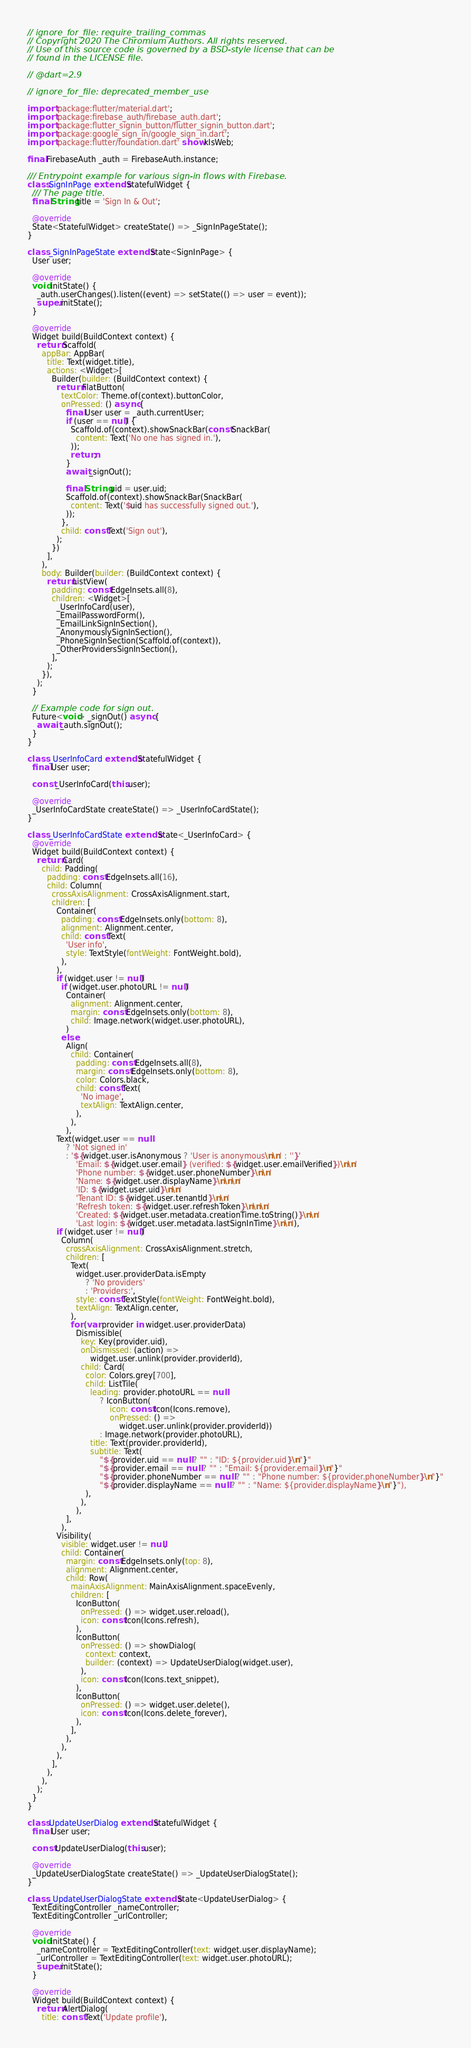Convert code to text. <code><loc_0><loc_0><loc_500><loc_500><_Dart_>// ignore_for_file: require_trailing_commas
// Copyright 2020 The Chromium Authors. All rights reserved.
// Use of this source code is governed by a BSD-style license that can be
// found in the LICENSE file.

// @dart=2.9

// ignore_for_file: deprecated_member_use

import 'package:flutter/material.dart';
import 'package:firebase_auth/firebase_auth.dart';
import 'package:flutter_signin_button/flutter_signin_button.dart';
import 'package:google_sign_in/google_sign_in.dart';
import 'package:flutter/foundation.dart' show kIsWeb;

final FirebaseAuth _auth = FirebaseAuth.instance;

/// Entrypoint example for various sign-in flows with Firebase.
class SignInPage extends StatefulWidget {
  /// The page title.
  final String title = 'Sign In & Out';

  @override
  State<StatefulWidget> createState() => _SignInPageState();
}

class _SignInPageState extends State<SignInPage> {
  User user;

  @override
  void initState() {
    _auth.userChanges().listen((event) => setState(() => user = event));
    super.initState();
  }

  @override
  Widget build(BuildContext context) {
    return Scaffold(
      appBar: AppBar(
        title: Text(widget.title),
        actions: <Widget>[
          Builder(builder: (BuildContext context) {
            return FlatButton(
              textColor: Theme.of(context).buttonColor,
              onPressed: () async {
                final User user = _auth.currentUser;
                if (user == null) {
                  Scaffold.of(context).showSnackBar(const SnackBar(
                    content: Text('No one has signed in.'),
                  ));
                  return;
                }
                await _signOut();

                final String uid = user.uid;
                Scaffold.of(context).showSnackBar(SnackBar(
                  content: Text('$uid has successfully signed out.'),
                ));
              },
              child: const Text('Sign out'),
            );
          })
        ],
      ),
      body: Builder(builder: (BuildContext context) {
        return ListView(
          padding: const EdgeInsets.all(8),
          children: <Widget>[
            _UserInfoCard(user),
            _EmailPasswordForm(),
            _EmailLinkSignInSection(),
            _AnonymouslySignInSection(),
            _PhoneSignInSection(Scaffold.of(context)),
            _OtherProvidersSignInSection(),
          ],
        );
      }),
    );
  }

  // Example code for sign out.
  Future<void> _signOut() async {
    await _auth.signOut();
  }
}

class _UserInfoCard extends StatefulWidget {
  final User user;

  const _UserInfoCard(this.user);

  @override
  _UserInfoCardState createState() => _UserInfoCardState();
}

class _UserInfoCardState extends State<_UserInfoCard> {
  @override
  Widget build(BuildContext context) {
    return Card(
      child: Padding(
        padding: const EdgeInsets.all(16),
        child: Column(
          crossAxisAlignment: CrossAxisAlignment.start,
          children: [
            Container(
              padding: const EdgeInsets.only(bottom: 8),
              alignment: Alignment.center,
              child: const Text(
                'User info',
                style: TextStyle(fontWeight: FontWeight.bold),
              ),
            ),
            if (widget.user != null)
              if (widget.user.photoURL != null)
                Container(
                  alignment: Alignment.center,
                  margin: const EdgeInsets.only(bottom: 8),
                  child: Image.network(widget.user.photoURL),
                )
              else
                Align(
                  child: Container(
                    padding: const EdgeInsets.all(8),
                    margin: const EdgeInsets.only(bottom: 8),
                    color: Colors.black,
                    child: const Text(
                      'No image',
                      textAlign: TextAlign.center,
                    ),
                  ),
                ),
            Text(widget.user == null
                ? 'Not signed in'
                : '${widget.user.isAnonymous ? 'User is anonymous\n\n' : ''}'
                    'Email: ${widget.user.email} (verified: ${widget.user.emailVerified})\n\n'
                    'Phone number: ${widget.user.phoneNumber}\n\n'
                    'Name: ${widget.user.displayName}\n\n\n'
                    'ID: ${widget.user.uid}\n\n'
                    'Tenant ID: ${widget.user.tenantId}\n\n'
                    'Refresh token: ${widget.user.refreshToken}\n\n\n'
                    'Created: ${widget.user.metadata.creationTime.toString()}\n\n'
                    'Last login: ${widget.user.metadata.lastSignInTime}\n\n'),
            if (widget.user != null)
              Column(
                crossAxisAlignment: CrossAxisAlignment.stretch,
                children: [
                  Text(
                    widget.user.providerData.isEmpty
                        ? 'No providers'
                        : 'Providers:',
                    style: const TextStyle(fontWeight: FontWeight.bold),
                    textAlign: TextAlign.center,
                  ),
                  for (var provider in widget.user.providerData)
                    Dismissible(
                      key: Key(provider.uid),
                      onDismissed: (action) =>
                          widget.user.unlink(provider.providerId),
                      child: Card(
                        color: Colors.grey[700],
                        child: ListTile(
                          leading: provider.photoURL == null
                              ? IconButton(
                                  icon: const Icon(Icons.remove),
                                  onPressed: () =>
                                      widget.user.unlink(provider.providerId))
                              : Image.network(provider.photoURL),
                          title: Text(provider.providerId),
                          subtitle: Text(
                              "${provider.uid == null ? "" : "ID: ${provider.uid}\n"}"
                              "${provider.email == null ? "" : "Email: ${provider.email}\n"}"
                              "${provider.phoneNumber == null ? "" : "Phone number: ${provider.phoneNumber}\n"}"
                              "${provider.displayName == null ? "" : "Name: ${provider.displayName}\n"}"),
                        ),
                      ),
                    ),
                ],
              ),
            Visibility(
              visible: widget.user != null,
              child: Container(
                margin: const EdgeInsets.only(top: 8),
                alignment: Alignment.center,
                child: Row(
                  mainAxisAlignment: MainAxisAlignment.spaceEvenly,
                  children: [
                    IconButton(
                      onPressed: () => widget.user.reload(),
                      icon: const Icon(Icons.refresh),
                    ),
                    IconButton(
                      onPressed: () => showDialog(
                        context: context,
                        builder: (context) => UpdateUserDialog(widget.user),
                      ),
                      icon: const Icon(Icons.text_snippet),
                    ),
                    IconButton(
                      onPressed: () => widget.user.delete(),
                      icon: const Icon(Icons.delete_forever),
                    ),
                  ],
                ),
              ),
            ),
          ],
        ),
      ),
    );
  }
}

class UpdateUserDialog extends StatefulWidget {
  final User user;

  const UpdateUserDialog(this.user);

  @override
  _UpdateUserDialogState createState() => _UpdateUserDialogState();
}

class _UpdateUserDialogState extends State<UpdateUserDialog> {
  TextEditingController _nameController;
  TextEditingController _urlController;

  @override
  void initState() {
    _nameController = TextEditingController(text: widget.user.displayName);
    _urlController = TextEditingController(text: widget.user.photoURL);
    super.initState();
  }

  @override
  Widget build(BuildContext context) {
    return AlertDialog(
      title: const Text('Update profile'),</code> 